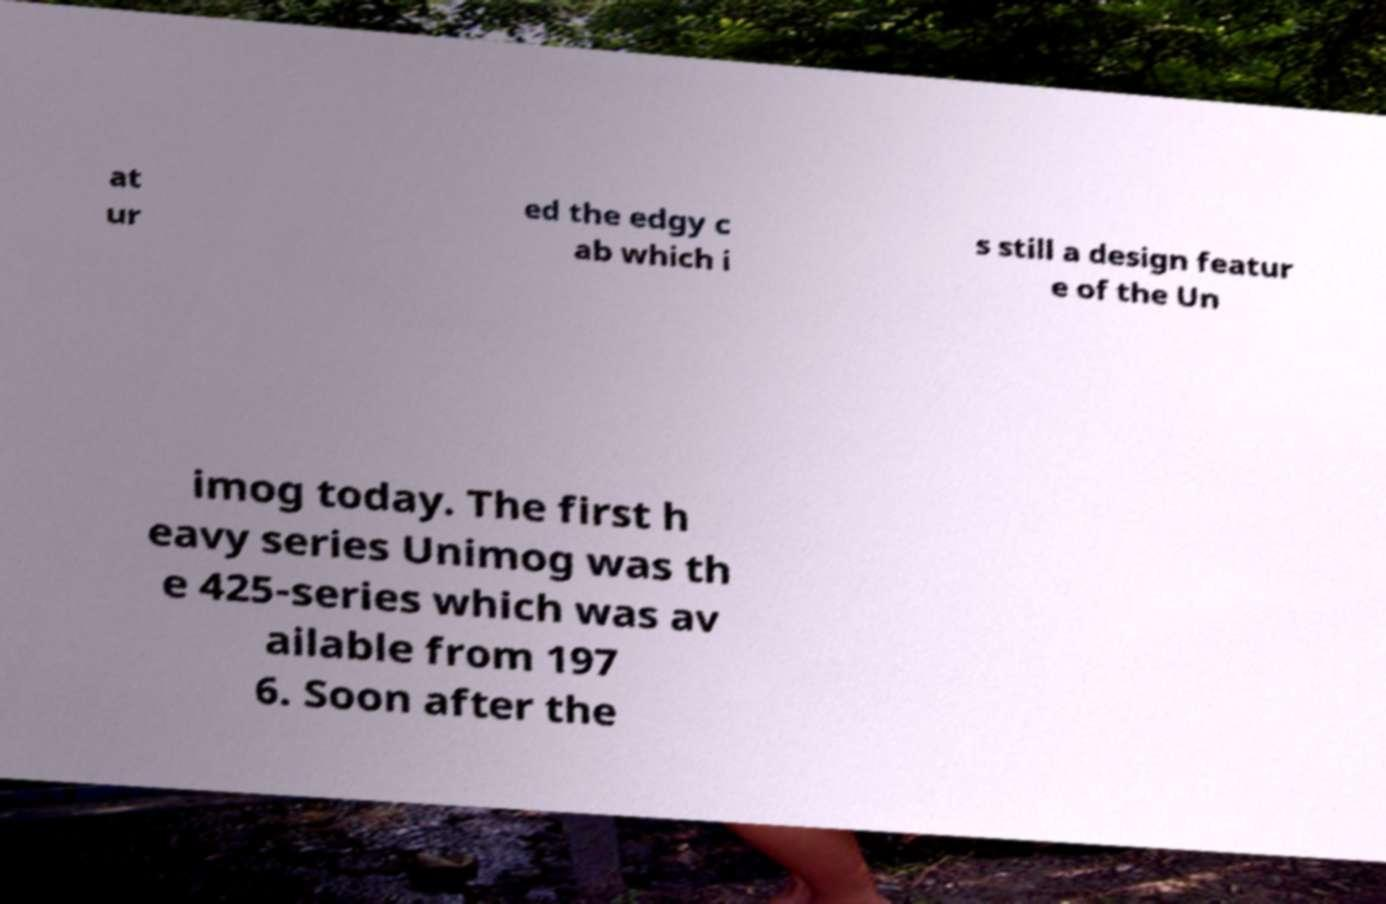Please read and relay the text visible in this image. What does it say? at ur ed the edgy c ab which i s still a design featur e of the Un imog today. The first h eavy series Unimog was th e 425-series which was av ailable from 197 6. Soon after the 